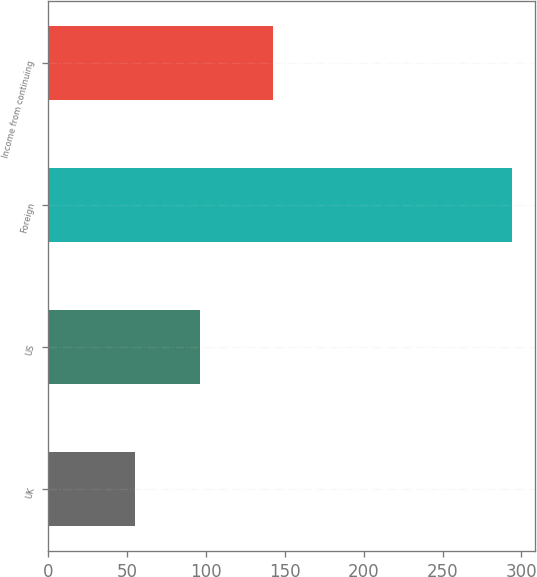<chart> <loc_0><loc_0><loc_500><loc_500><bar_chart><fcel>UK<fcel>US<fcel>Foreign<fcel>Income from continuing<nl><fcel>55.4<fcel>96.4<fcel>294.1<fcel>142.3<nl></chart> 